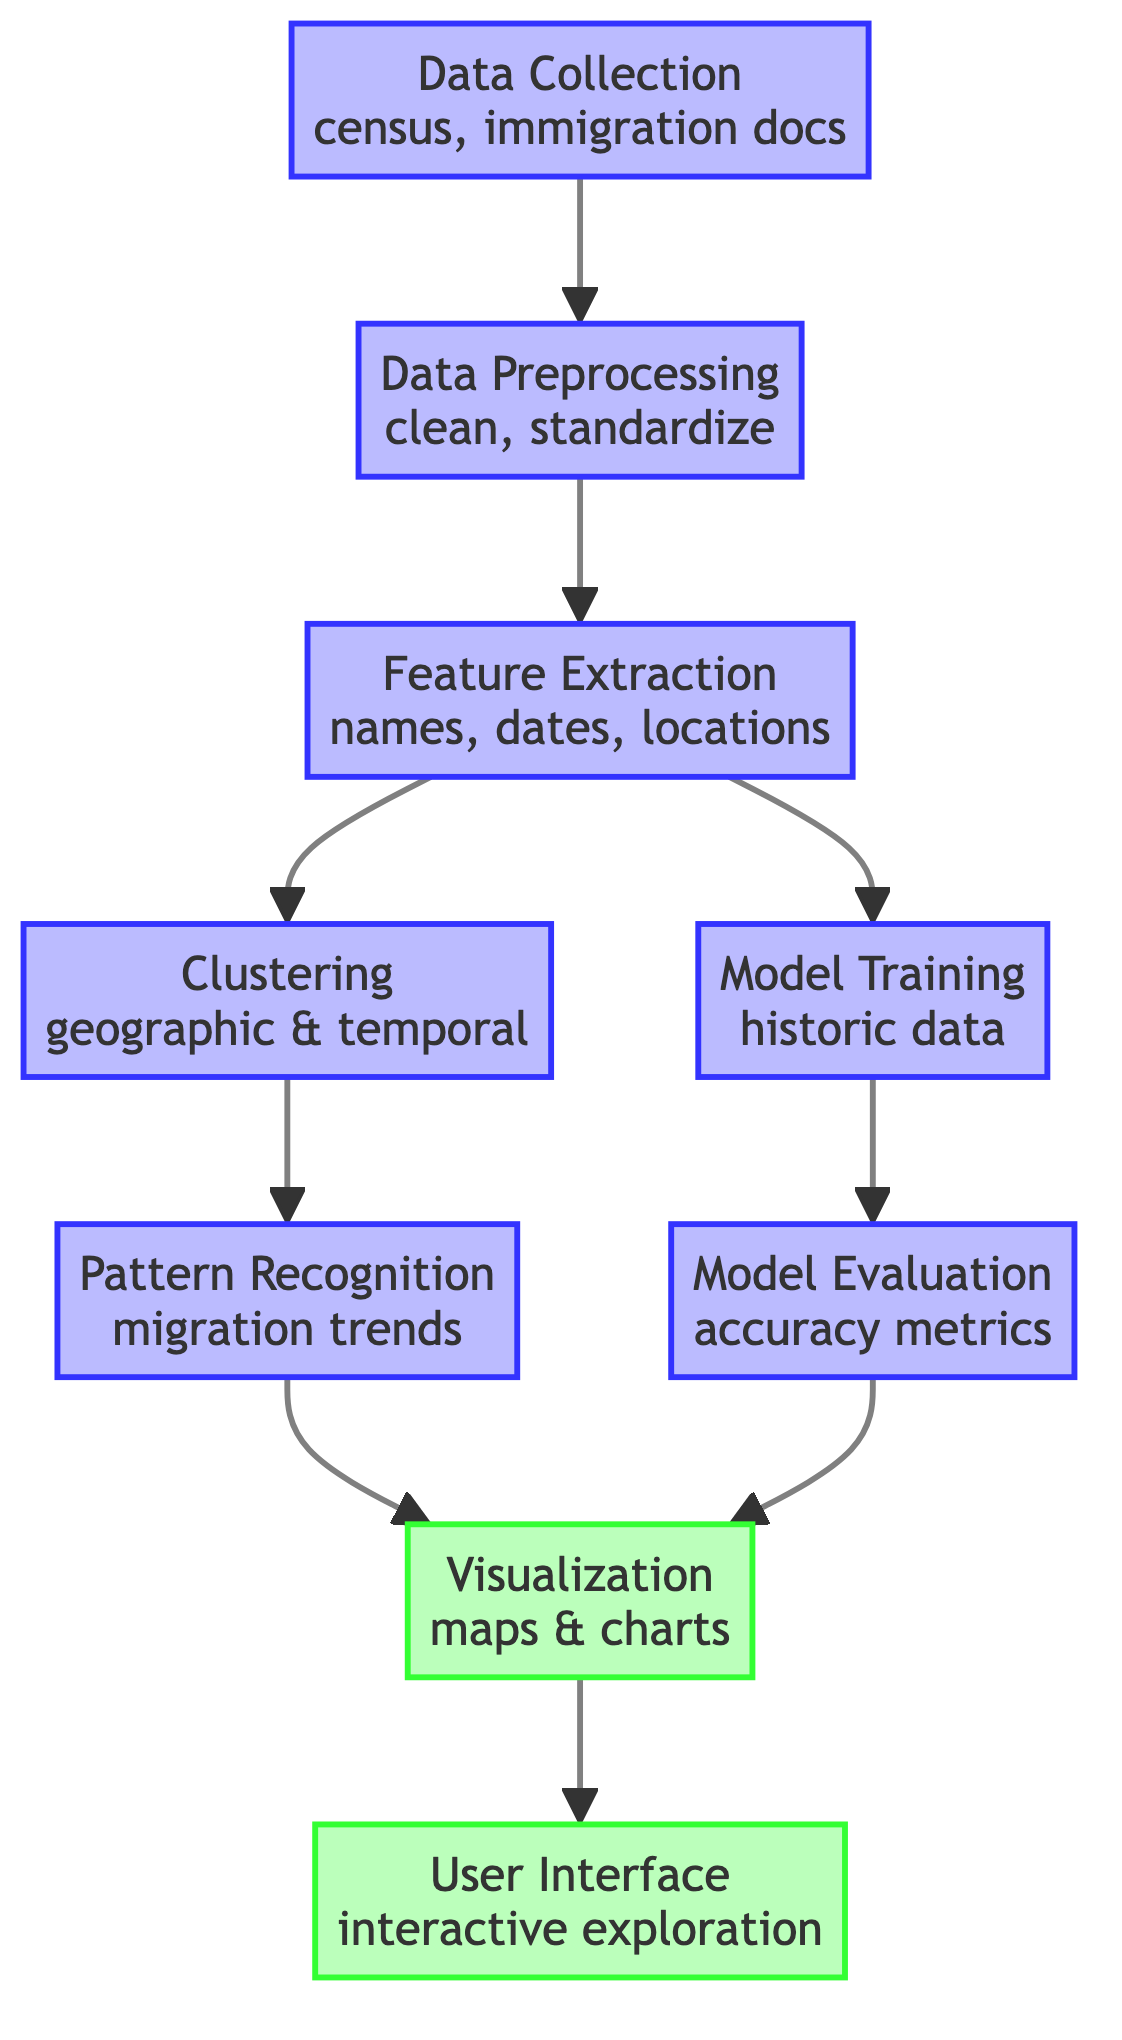What is the first step in the diagram? The diagram shows that the first step is "Data Collection" which involves gathering information from census and immigration documents.
Answer: Data Collection How many output nodes are there in the diagram? By examining the diagram, there are two output nodes: "Visualization" and "User Interface."
Answer: 2 What type of processing is done after "Data Preprocessing"? After "Data Preprocessing," the next step is "Feature Extraction," which involves extracting relevant features such as names, dates, and locations.
Answer: Feature Extraction Which step follows "Model Training"? The step that follows "Model Training" is "Model Evaluation," where the model is assessed using accuracy metrics.
Answer: Model Evaluation What two nodes connect to "Clustering"? "Feature Extraction" and "Data Preprocessing" both connect to "Clustering," indicating that they provide the necessary input for this process.
Answer: Feature Extraction, Data Preprocessing What is the final output of the process? The final output node is "User Interface," which allows users to interactively explore the results of the migration pattern analysis.
Answer: User Interface What is involved in "Pattern Recognition"? "Pattern Recognition" involves identifying migration trends based on the results of clustering with geographic and temporal data.
Answer: Migration trends Which step comes after "Visualization"? The step that comes after "Visualization" is "User Interface," indicating that the visualizations will feed into an interface for exploration.
Answer: User Interface What does the "Model Evaluation" step measure? The "Model Evaluation" step measures the accuracy metrics of the model that has been trained on historic data.
Answer: Accuracy metrics 